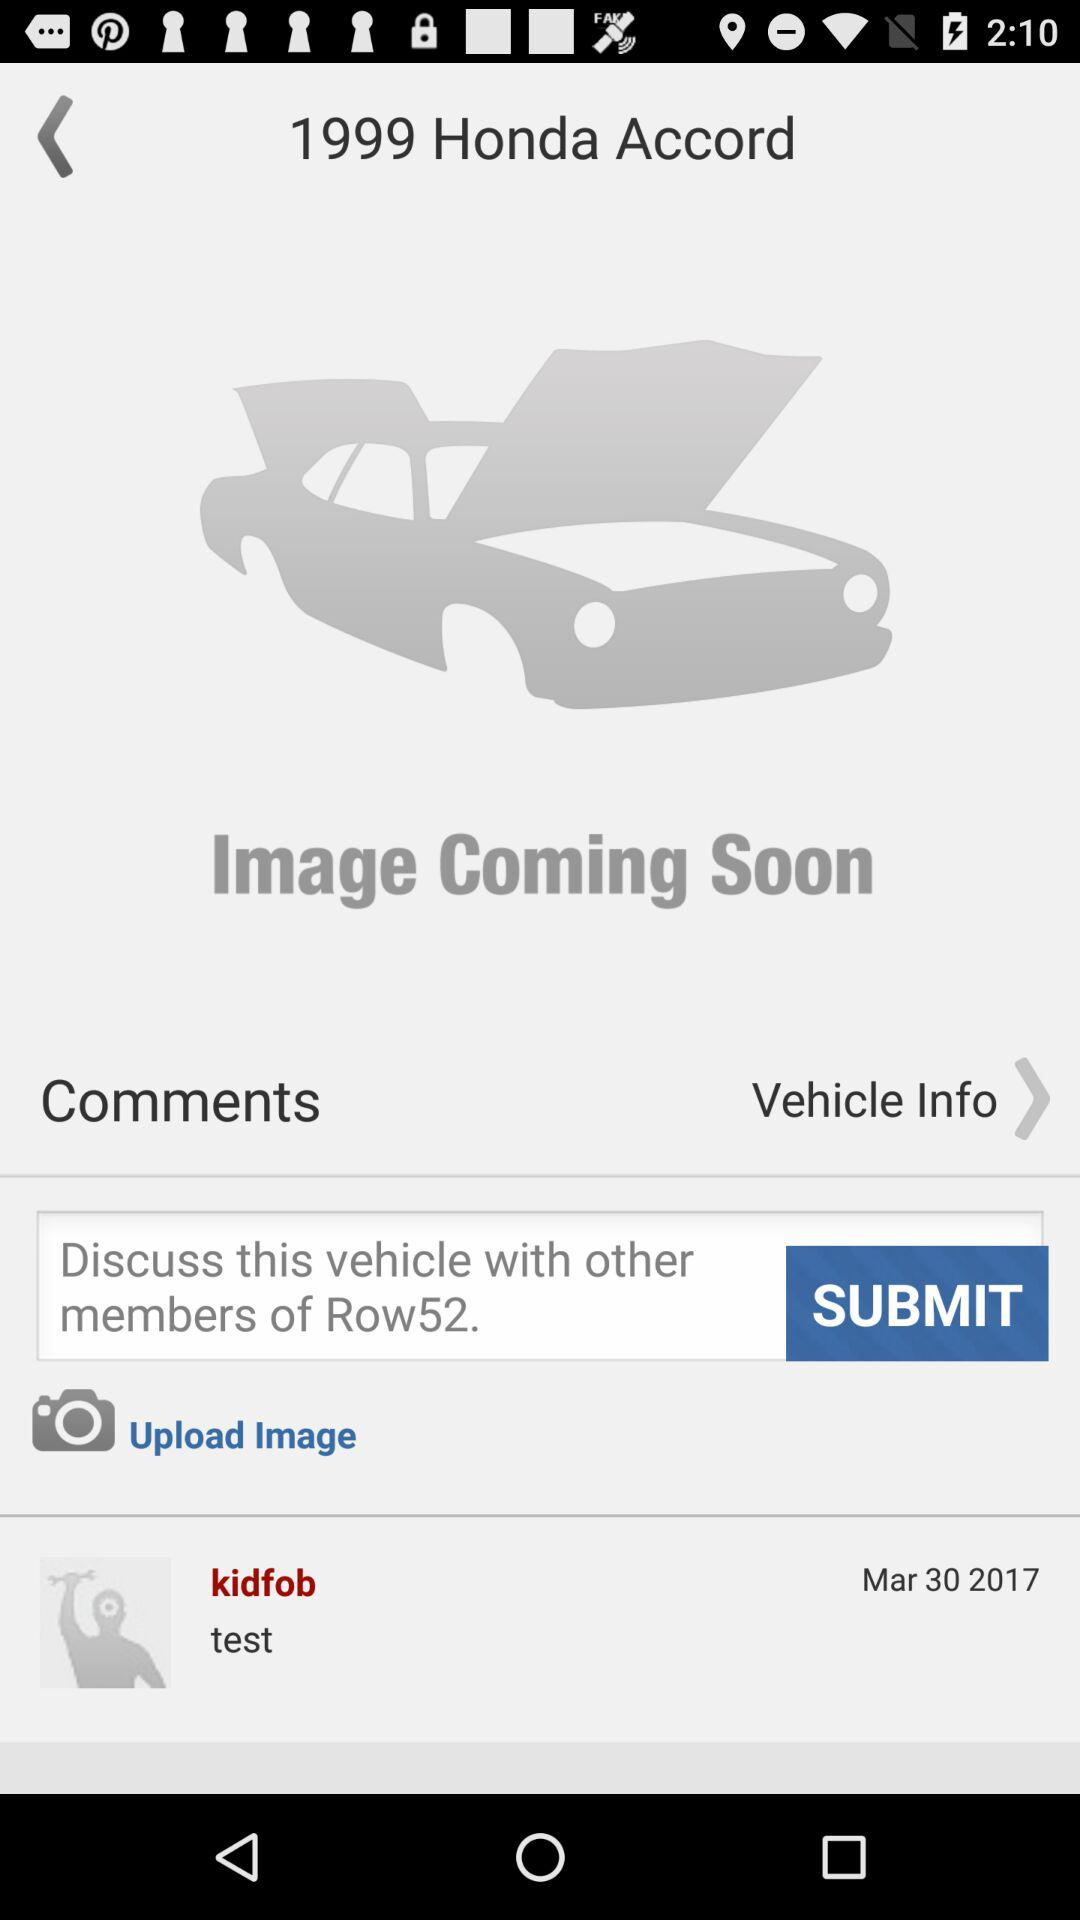How many miles are on the 1999 Honda Accord?
When the provided information is insufficient, respond with <no answer>. <no answer> 